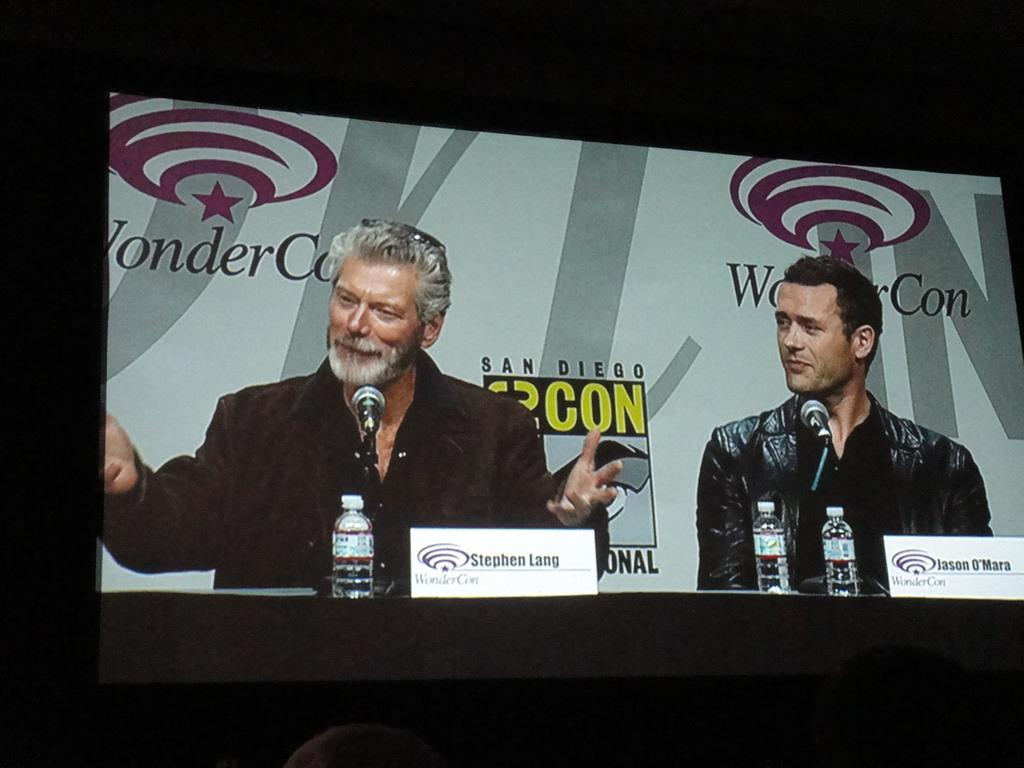What is the main object in the image? There is a screen in the image. Who is present in front of the screen? Two men are sitting in front of the screen. What can be seen behind the men? There is a banner behind the men. How many people are visible in the image? There are two people in front of the screen. Is there a cobweb visible on the screen in the image? There is no mention of a cobweb in the provided facts, so we cannot determine if one is present in the image. What type of disease is the sister of one of the men suffering from? There is no mention of a sister or a disease in the provided facts, so we cannot answer this question. 